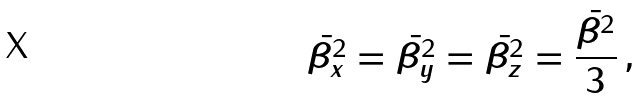<formula> <loc_0><loc_0><loc_500><loc_500>\bar { \beta _ { x } ^ { 2 } } = \bar { \beta _ { y } ^ { 2 } } = \bar { \beta _ { z } ^ { 2 } } = \frac { \bar { \beta ^ { 2 } } } { 3 } \, ,</formula> 